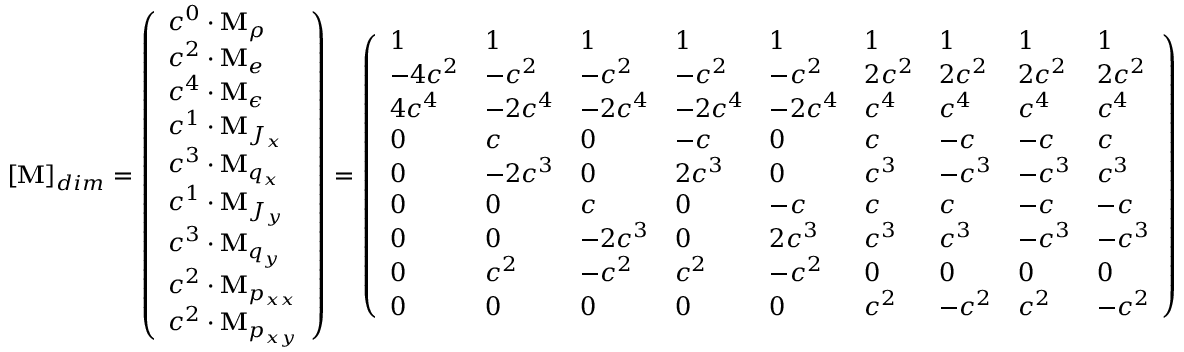Convert formula to latex. <formula><loc_0><loc_0><loc_500><loc_500>[ M ] _ { d i m } = \left ( \begin{array} { l } { c ^ { 0 } \cdot M _ { \rho } } \\ { c ^ { 2 } \cdot M _ { e } } \\ { c ^ { 4 } \cdot M _ { \epsilon } } \\ { c ^ { 1 } \cdot M _ { J _ { x } } } \\ { c ^ { 3 } \cdot M _ { q _ { x } } } \\ { c ^ { 1 } \cdot M _ { J _ { y } } } \\ { c ^ { 3 } \cdot M _ { q _ { y } } } \\ { c ^ { 2 } \cdot M _ { p _ { x x } } } \\ { c ^ { 2 } \cdot M _ { p _ { x y } } } \end{array} \right ) = \left ( \begin{array} { l l l l l l l l l } { 1 } & { 1 } & { 1 } & { 1 } & { 1 } & { 1 } & { 1 } & { 1 } & { 1 } \\ { - 4 c ^ { 2 } } & { - c ^ { 2 } } & { - c ^ { 2 } } & { - c ^ { 2 } } & { - c ^ { 2 } } & { 2 c ^ { 2 } } & { 2 c ^ { 2 } } & { 2 c ^ { 2 } } & { 2 c ^ { 2 } } \\ { 4 c ^ { 4 } } & { - 2 c ^ { 4 } } & { - 2 c ^ { 4 } } & { - 2 c ^ { 4 } } & { - 2 c ^ { 4 } } & { c ^ { 4 } } & { c ^ { 4 } } & { c ^ { 4 } } & { c ^ { 4 } } \\ { 0 } & { c } & { 0 } & { - c } & { 0 } & { c } & { - c } & { - c } & { c } \\ { 0 } & { - 2 c ^ { 3 } } & { 0 } & { 2 c ^ { 3 } } & { 0 } & { c ^ { 3 } } & { - c ^ { 3 } } & { - c ^ { 3 } } & { c ^ { 3 } } \\ { 0 } & { 0 } & { c } & { 0 } & { - c } & { c } & { c } & { - c } & { - c } \\ { 0 } & { 0 } & { - 2 c ^ { 3 } } & { 0 } & { 2 c ^ { 3 } } & { c ^ { 3 } } & { c ^ { 3 } } & { - c ^ { 3 } } & { - c ^ { 3 } } \\ { 0 } & { c ^ { 2 } } & { - c ^ { 2 } } & { c ^ { 2 } } & { - c ^ { 2 } } & { 0 } & { 0 } & { 0 } & { 0 } \\ { 0 } & { 0 } & { 0 } & { 0 } & { 0 } & { c ^ { 2 } } & { - c ^ { 2 } } & { c ^ { 2 } } & { - c ^ { 2 } } \end{array} \right )</formula> 